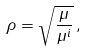Convert formula to latex. <formula><loc_0><loc_0><loc_500><loc_500>\rho = \sqrt { \frac { \mu } { \mu ^ { i } } } \, ,</formula> 